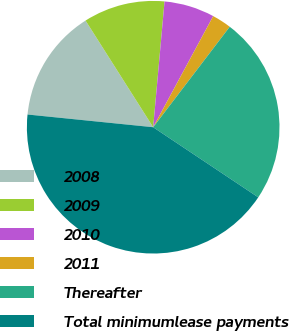Convert chart. <chart><loc_0><loc_0><loc_500><loc_500><pie_chart><fcel>2008<fcel>2009<fcel>2010<fcel>2011<fcel>Thereafter<fcel>Total minimumlease payments<nl><fcel>14.4%<fcel>10.43%<fcel>6.45%<fcel>2.48%<fcel>24.0%<fcel>42.24%<nl></chart> 